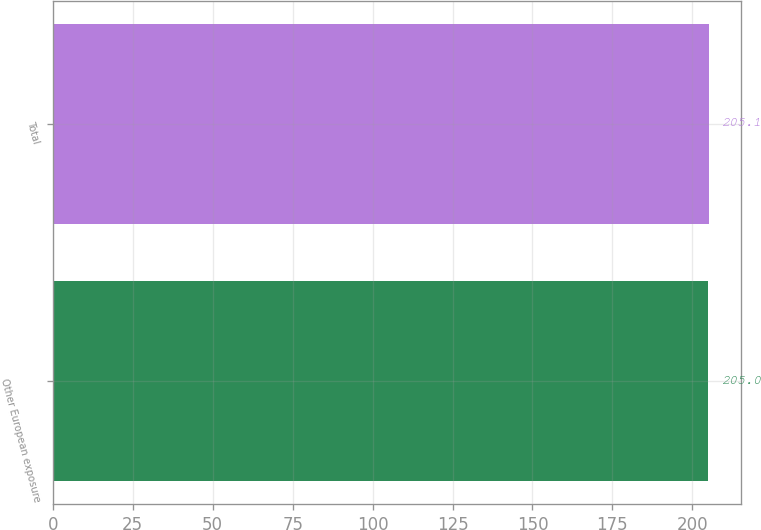Convert chart. <chart><loc_0><loc_0><loc_500><loc_500><bar_chart><fcel>Other European exposure<fcel>Total<nl><fcel>205<fcel>205.1<nl></chart> 